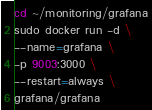<code> <loc_0><loc_0><loc_500><loc_500><_Bash_>cd ~/monitoring/grafana
sudo docker run -d \
--name=grafana \
-p 9003:3000 \
--restart=always \
grafana/grafana
</code> 